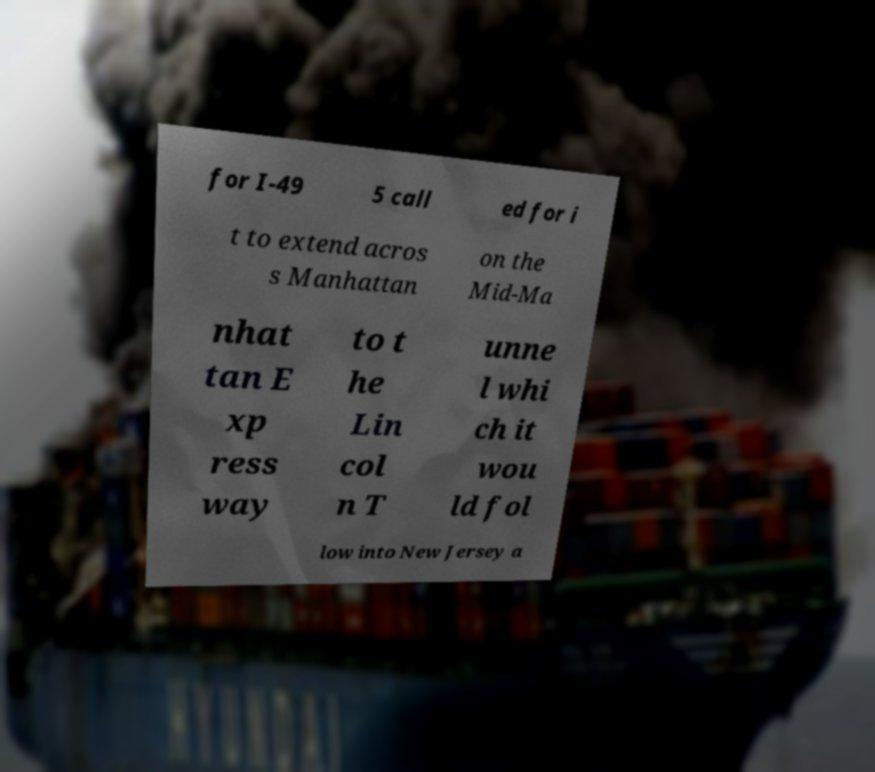Could you assist in decoding the text presented in this image and type it out clearly? for I-49 5 call ed for i t to extend acros s Manhattan on the Mid-Ma nhat tan E xp ress way to t he Lin col n T unne l whi ch it wou ld fol low into New Jersey a 